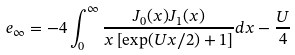Convert formula to latex. <formula><loc_0><loc_0><loc_500><loc_500>e _ { \infty } = - 4 \int _ { 0 } ^ { \infty } \frac { J _ { 0 } ( x ) J _ { 1 } ( x ) } { x \left [ \exp ( U x / 2 ) + 1 \right ] } d x - \frac { U } { 4 }</formula> 